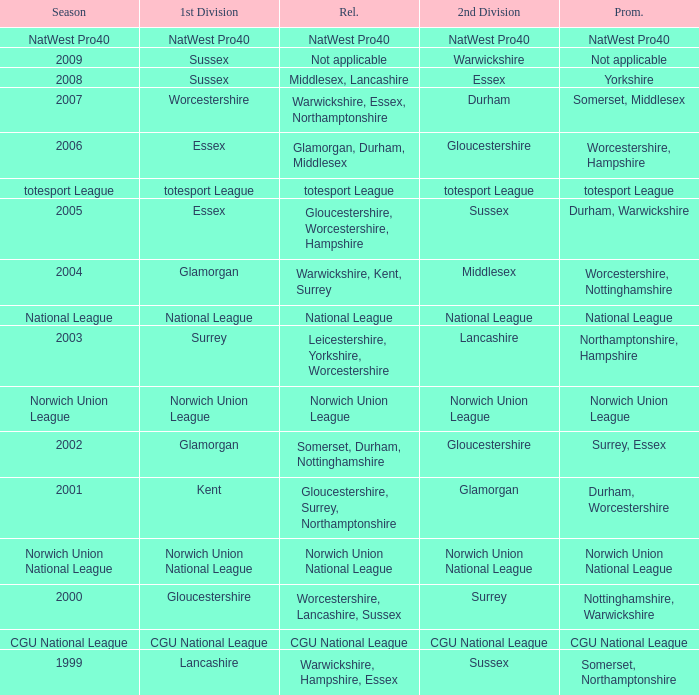What is the 1st division when the 2nd division is national league? National League. 